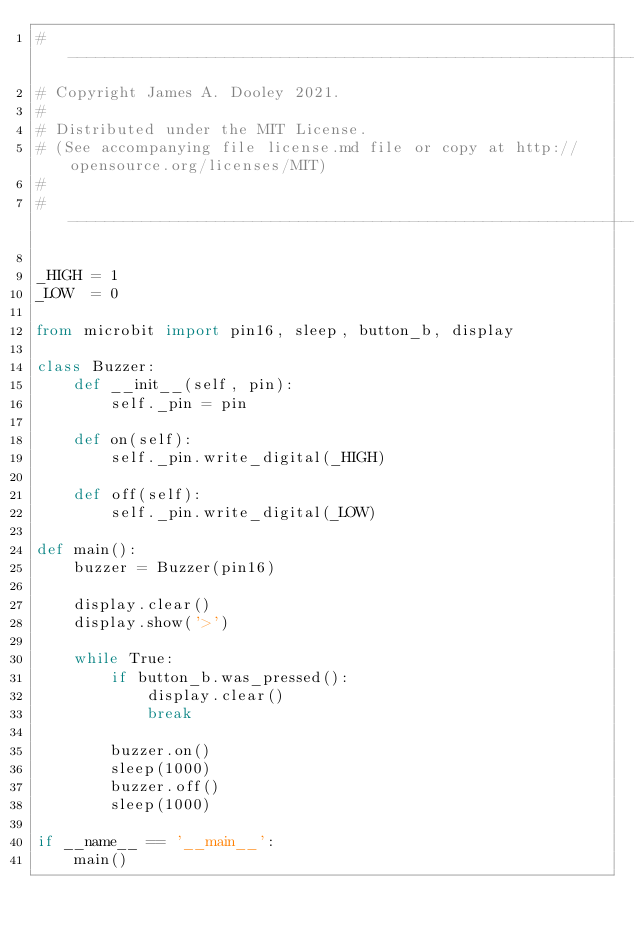Convert code to text. <code><loc_0><loc_0><loc_500><loc_500><_Python_># ------------------------------------------------------------------------------------------
# Copyright James A. Dooley 2021.
#
# Distributed under the MIT License.
# (See accompanying file license.md file or copy at http://opensource.org/licenses/MIT)
#
# ------------------------------------------------------------------------------------------

_HIGH = 1
_LOW  = 0

from microbit import pin16, sleep, button_b, display

class Buzzer:
    def __init__(self, pin):
        self._pin = pin
        
    def on(self):
        self._pin.write_digital(_HIGH)

    def off(self):
        self._pin.write_digital(_LOW)
        
def main():
    buzzer = Buzzer(pin16)

    display.clear()
    display.show('>')
    
    while True:
        if button_b.was_pressed():
            display.clear()
            break
        
        buzzer.on()
        sleep(1000)
        buzzer.off()
        sleep(1000)
        
if __name__ == '__main__':
    main()
</code> 